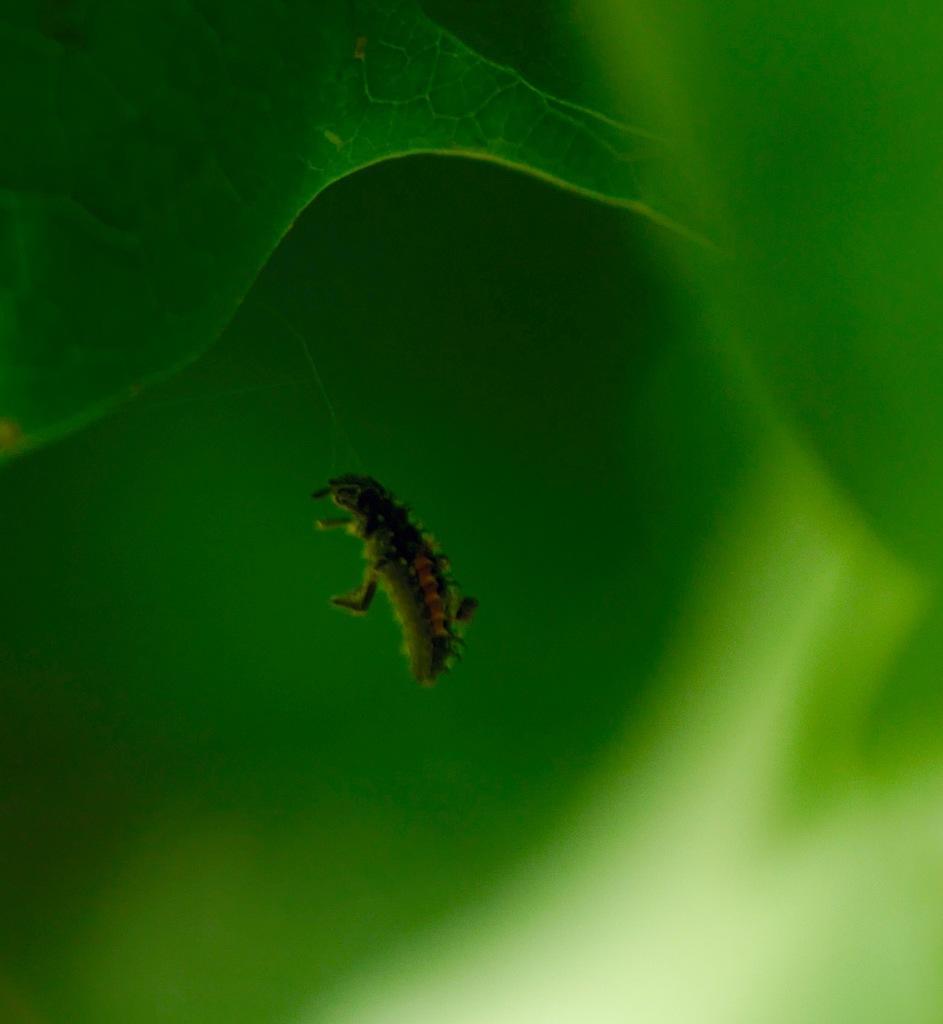Could you give a brief overview of what you see in this image? In this image we can see some pest and there are some leaves. 